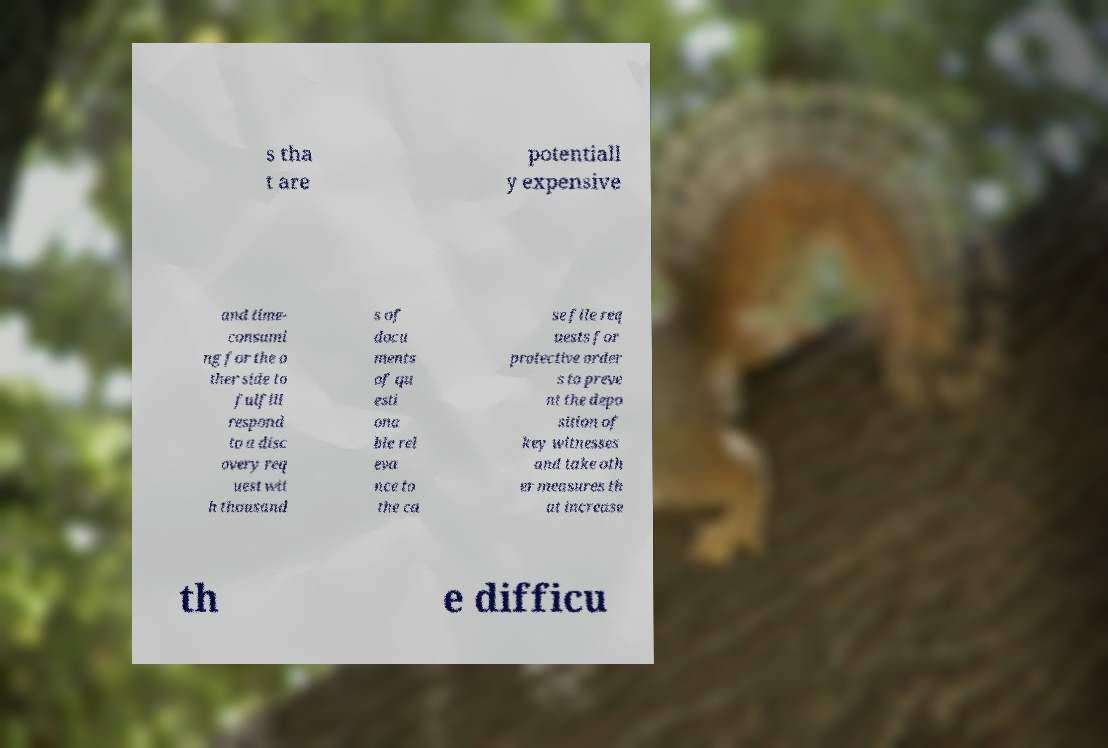What messages or text are displayed in this image? I need them in a readable, typed format. s tha t are potentiall y expensive and time- consumi ng for the o ther side to fulfill respond to a disc overy req uest wit h thousand s of docu ments of qu esti ona ble rel eva nce to the ca se file req uests for protective order s to preve nt the depo sition of key witnesses and take oth er measures th at increase th e difficu 